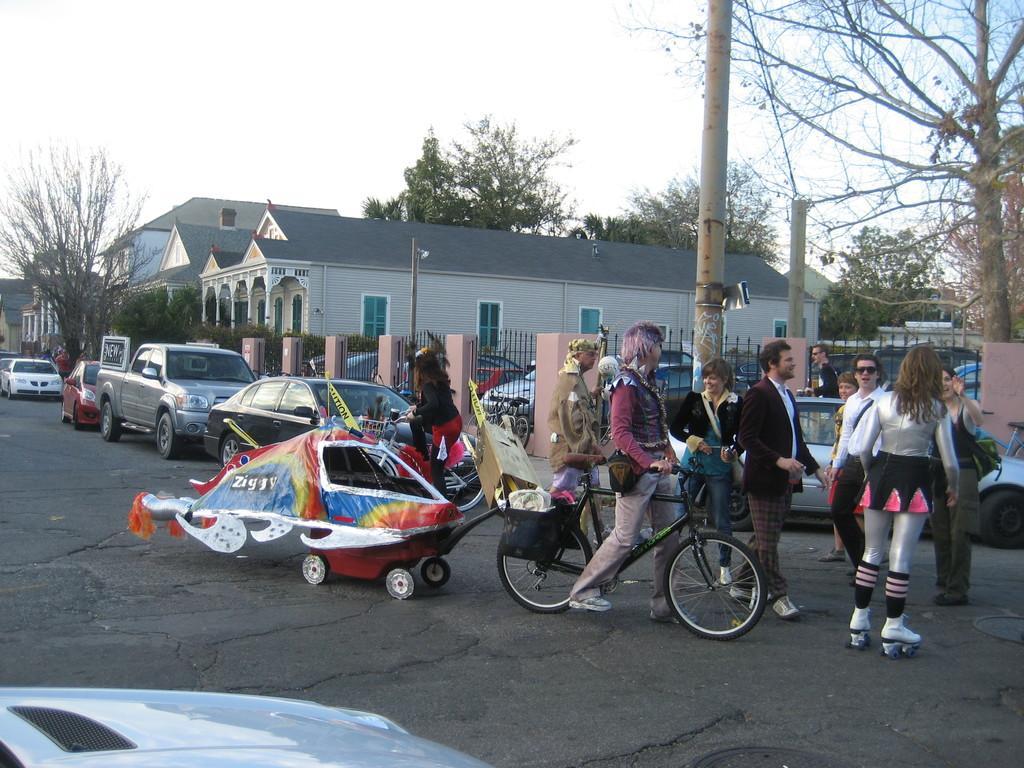Describe this image in one or two sentences. In the image we can see there is a clear sky and there are buildings and there are lot of trees in the area. There are cars which are parked on the road. There is a bicycle and the man is holding a bicycle, the woman is standing on the roller skates. 